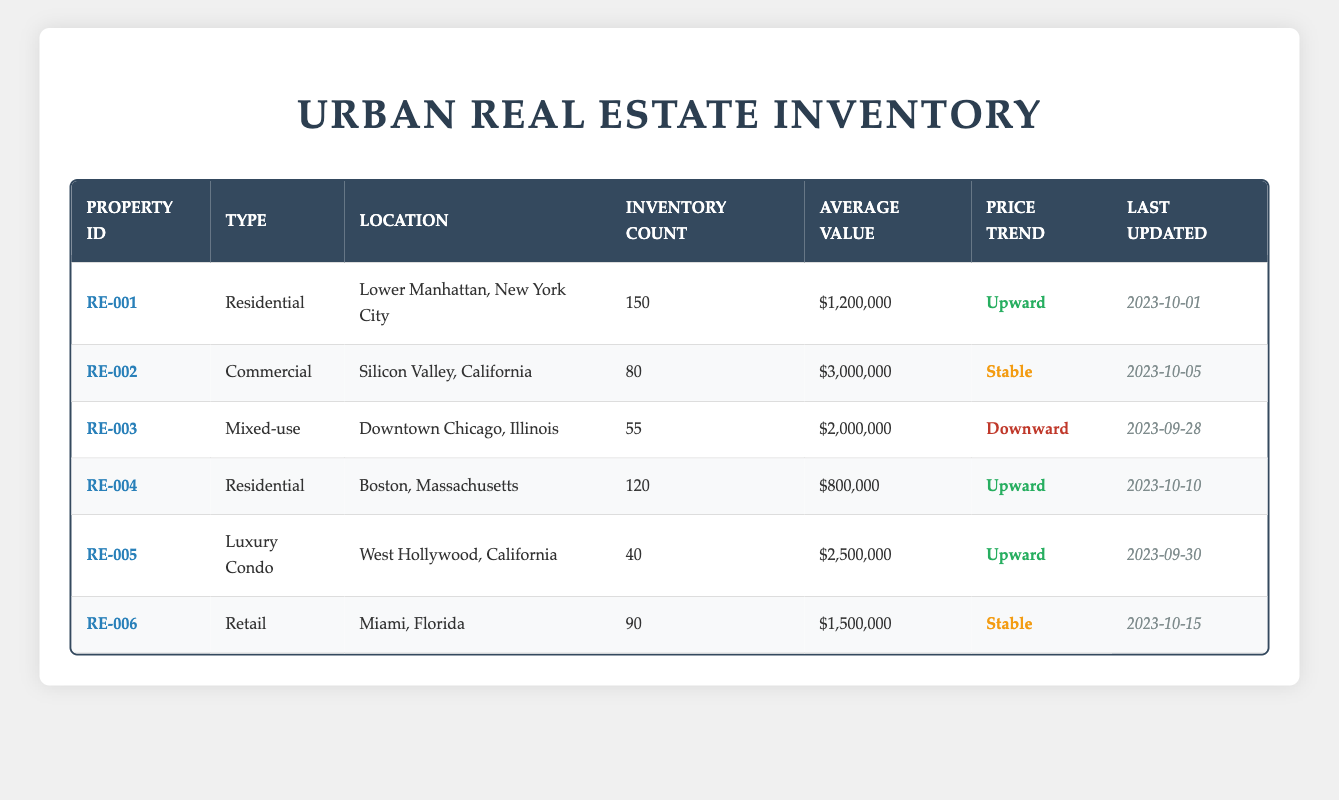What is the average value of residential properties in the inventory? There are two residential properties listed: one in Lower Manhattan with an average value of 1,200,000 and another in Boston with an average value of 800,000. To find the average, we add these values: 1,200,000 + 800,000 = 2,000,000. Then, we divide by the number of residential properties, which is 2: 2,000,000 / 2 = 1,000,000.
Answer: 1,000,000 Which property has the highest inventory count? Reviewing the inventory counts, Lower Manhattan has 150, the Silicon Valley has 80, Downtown Chicago has 55, Boston has 120, West Hollywood has 40, and Miami has 90. The highest is 150 in Lower Manhattan.
Answer: Lower Manhattan Is the price trend for luxury condos upward? The price trend for luxury condos in West Hollywood is listed as upward. Therefore, the statement is true.
Answer: Yes What is the total inventory count of commercial and mixed-use properties? The commercial property in Silicon Valley has an inventory count of 80, while the mixed-use property in Downtown Chicago has 55. Adding these counts gives us 80 + 55 = 135.
Answer: 135 What was the last updated date for the property with the highest average value? Looking at the average values, the commercial property in Silicon Valley has the highest average value of 3,000,000. The last updated date for this property is 2023-10-05.
Answer: 2023-10-05 Are there any properties in the inventory with a downward price trend? There is one property listed with a downward price trend: the mixed-use property in Downtown Chicago. Thus, the answer is yes.
Answer: Yes What is the price difference between the most expensive and least expensive property? The most expensive property is commercial in Silicon Valley at 3,000,000, and the least expensive is the residential property in Boston at 800,000. The price difference is 3,000,000 - 800,000 = 2,200,000.
Answer: 2,200,000 How many urban properties have stable price trends? The retail property in Miami and the commercial property in Silicon Valley both have stable price trends. Thus, there are two urban properties with stable trends.
Answer: 2 Which city has a downward price trend, and how many properties are located there? The only property with a downward price trend is located in Downtown Chicago, which has 55 properties in the inventory.
Answer: Downtown Chicago, 55 What is the average value of properties located in California? The properties in California include the commercial property in Silicon Valley with an average value of 3,000,000 and the luxury condo in West Hollywood valued at 2,500,000. Adding these values gives us 3,000,000 + 2,500,000 = 5,500,000. Dividing this by 2 (the number of properties) results in an average value of 2,750,000.
Answer: 2,750,000 